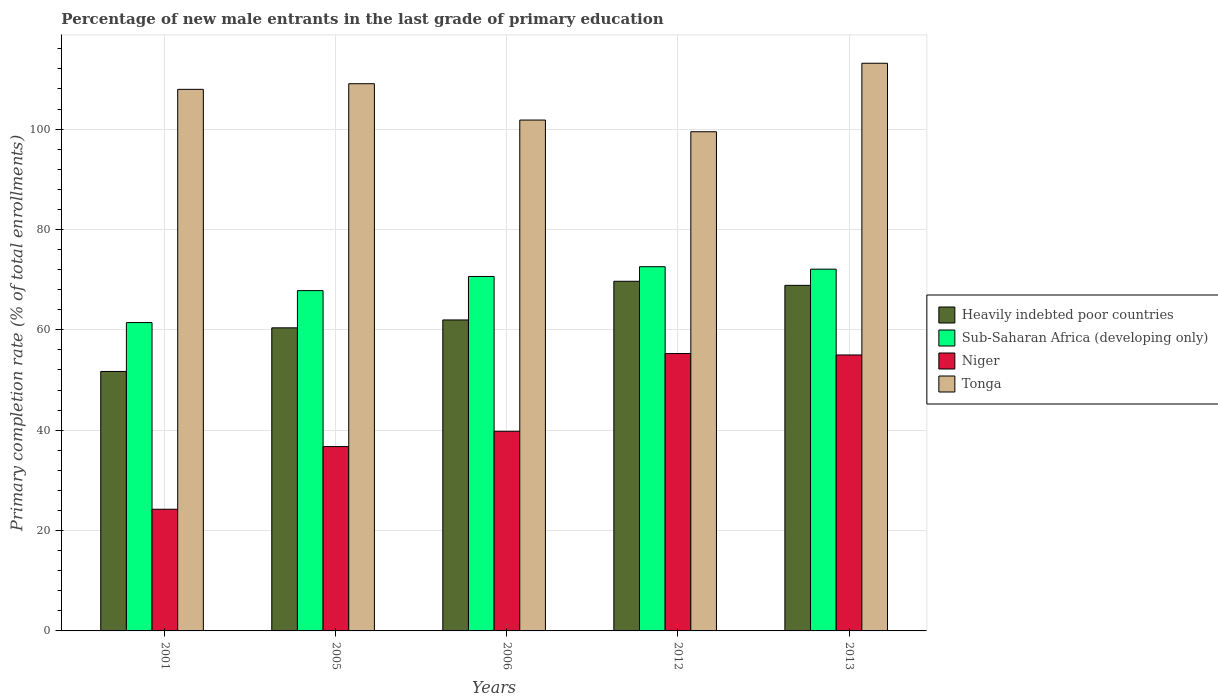How many groups of bars are there?
Ensure brevity in your answer.  5. Are the number of bars on each tick of the X-axis equal?
Offer a very short reply. Yes. What is the label of the 5th group of bars from the left?
Provide a succinct answer. 2013. In how many cases, is the number of bars for a given year not equal to the number of legend labels?
Offer a very short reply. 0. What is the percentage of new male entrants in Sub-Saharan Africa (developing only) in 2006?
Give a very brief answer. 70.63. Across all years, what is the maximum percentage of new male entrants in Heavily indebted poor countries?
Provide a short and direct response. 69.68. Across all years, what is the minimum percentage of new male entrants in Sub-Saharan Africa (developing only)?
Provide a succinct answer. 61.45. In which year was the percentage of new male entrants in Sub-Saharan Africa (developing only) maximum?
Give a very brief answer. 2012. In which year was the percentage of new male entrants in Heavily indebted poor countries minimum?
Offer a very short reply. 2001. What is the total percentage of new male entrants in Niger in the graph?
Offer a very short reply. 211.03. What is the difference between the percentage of new male entrants in Heavily indebted poor countries in 2001 and that in 2006?
Your answer should be very brief. -10.27. What is the difference between the percentage of new male entrants in Heavily indebted poor countries in 2005 and the percentage of new male entrants in Tonga in 2006?
Offer a terse response. -41.4. What is the average percentage of new male entrants in Heavily indebted poor countries per year?
Keep it short and to the point. 62.52. In the year 2001, what is the difference between the percentage of new male entrants in Sub-Saharan Africa (developing only) and percentage of new male entrants in Niger?
Your answer should be very brief. 37.2. In how many years, is the percentage of new male entrants in Sub-Saharan Africa (developing only) greater than 108 %?
Offer a terse response. 0. What is the ratio of the percentage of new male entrants in Sub-Saharan Africa (developing only) in 2001 to that in 2006?
Your answer should be very brief. 0.87. What is the difference between the highest and the second highest percentage of new male entrants in Niger?
Provide a short and direct response. 0.28. What is the difference between the highest and the lowest percentage of new male entrants in Sub-Saharan Africa (developing only)?
Ensure brevity in your answer.  11.13. In how many years, is the percentage of new male entrants in Heavily indebted poor countries greater than the average percentage of new male entrants in Heavily indebted poor countries taken over all years?
Offer a terse response. 2. Is it the case that in every year, the sum of the percentage of new male entrants in Niger and percentage of new male entrants in Heavily indebted poor countries is greater than the sum of percentage of new male entrants in Sub-Saharan Africa (developing only) and percentage of new male entrants in Tonga?
Provide a short and direct response. No. What does the 2nd bar from the left in 2001 represents?
Offer a very short reply. Sub-Saharan Africa (developing only). What does the 4th bar from the right in 2005 represents?
Your answer should be very brief. Heavily indebted poor countries. Are all the bars in the graph horizontal?
Offer a terse response. No. Are the values on the major ticks of Y-axis written in scientific E-notation?
Offer a terse response. No. Does the graph contain any zero values?
Provide a short and direct response. No. Does the graph contain grids?
Make the answer very short. Yes. How are the legend labels stacked?
Keep it short and to the point. Vertical. What is the title of the graph?
Offer a very short reply. Percentage of new male entrants in the last grade of primary education. Does "Zimbabwe" appear as one of the legend labels in the graph?
Provide a short and direct response. No. What is the label or title of the Y-axis?
Offer a very short reply. Primary completion rate (% of total enrollments). What is the Primary completion rate (% of total enrollments) in Heavily indebted poor countries in 2001?
Keep it short and to the point. 51.7. What is the Primary completion rate (% of total enrollments) of Sub-Saharan Africa (developing only) in 2001?
Your answer should be compact. 61.45. What is the Primary completion rate (% of total enrollments) in Niger in 2001?
Your answer should be compact. 24.25. What is the Primary completion rate (% of total enrollments) of Tonga in 2001?
Offer a very short reply. 107.92. What is the Primary completion rate (% of total enrollments) in Heavily indebted poor countries in 2005?
Offer a terse response. 60.4. What is the Primary completion rate (% of total enrollments) of Sub-Saharan Africa (developing only) in 2005?
Provide a succinct answer. 67.81. What is the Primary completion rate (% of total enrollments) of Niger in 2005?
Offer a very short reply. 36.73. What is the Primary completion rate (% of total enrollments) of Tonga in 2005?
Your answer should be very brief. 109.04. What is the Primary completion rate (% of total enrollments) of Heavily indebted poor countries in 2006?
Offer a very short reply. 61.97. What is the Primary completion rate (% of total enrollments) of Sub-Saharan Africa (developing only) in 2006?
Your answer should be compact. 70.63. What is the Primary completion rate (% of total enrollments) of Niger in 2006?
Ensure brevity in your answer.  39.78. What is the Primary completion rate (% of total enrollments) of Tonga in 2006?
Your answer should be very brief. 101.8. What is the Primary completion rate (% of total enrollments) in Heavily indebted poor countries in 2012?
Your response must be concise. 69.68. What is the Primary completion rate (% of total enrollments) in Sub-Saharan Africa (developing only) in 2012?
Make the answer very short. 72.57. What is the Primary completion rate (% of total enrollments) in Niger in 2012?
Keep it short and to the point. 55.28. What is the Primary completion rate (% of total enrollments) of Tonga in 2012?
Offer a very short reply. 99.47. What is the Primary completion rate (% of total enrollments) in Heavily indebted poor countries in 2013?
Ensure brevity in your answer.  68.86. What is the Primary completion rate (% of total enrollments) of Sub-Saharan Africa (developing only) in 2013?
Your response must be concise. 72.08. What is the Primary completion rate (% of total enrollments) of Niger in 2013?
Provide a succinct answer. 54.99. What is the Primary completion rate (% of total enrollments) in Tonga in 2013?
Your answer should be compact. 113.12. Across all years, what is the maximum Primary completion rate (% of total enrollments) of Heavily indebted poor countries?
Your answer should be compact. 69.68. Across all years, what is the maximum Primary completion rate (% of total enrollments) of Sub-Saharan Africa (developing only)?
Offer a terse response. 72.57. Across all years, what is the maximum Primary completion rate (% of total enrollments) of Niger?
Provide a short and direct response. 55.28. Across all years, what is the maximum Primary completion rate (% of total enrollments) of Tonga?
Offer a very short reply. 113.12. Across all years, what is the minimum Primary completion rate (% of total enrollments) in Heavily indebted poor countries?
Provide a succinct answer. 51.7. Across all years, what is the minimum Primary completion rate (% of total enrollments) of Sub-Saharan Africa (developing only)?
Give a very brief answer. 61.45. Across all years, what is the minimum Primary completion rate (% of total enrollments) of Niger?
Your response must be concise. 24.25. Across all years, what is the minimum Primary completion rate (% of total enrollments) of Tonga?
Offer a very short reply. 99.47. What is the total Primary completion rate (% of total enrollments) of Heavily indebted poor countries in the graph?
Provide a short and direct response. 312.6. What is the total Primary completion rate (% of total enrollments) in Sub-Saharan Africa (developing only) in the graph?
Make the answer very short. 344.55. What is the total Primary completion rate (% of total enrollments) in Niger in the graph?
Offer a terse response. 211.03. What is the total Primary completion rate (% of total enrollments) in Tonga in the graph?
Offer a terse response. 531.35. What is the difference between the Primary completion rate (% of total enrollments) in Heavily indebted poor countries in 2001 and that in 2005?
Ensure brevity in your answer.  -8.7. What is the difference between the Primary completion rate (% of total enrollments) of Sub-Saharan Africa (developing only) in 2001 and that in 2005?
Keep it short and to the point. -6.37. What is the difference between the Primary completion rate (% of total enrollments) in Niger in 2001 and that in 2005?
Offer a terse response. -12.49. What is the difference between the Primary completion rate (% of total enrollments) of Tonga in 2001 and that in 2005?
Your response must be concise. -1.12. What is the difference between the Primary completion rate (% of total enrollments) of Heavily indebted poor countries in 2001 and that in 2006?
Provide a short and direct response. -10.27. What is the difference between the Primary completion rate (% of total enrollments) in Sub-Saharan Africa (developing only) in 2001 and that in 2006?
Give a very brief answer. -9.18. What is the difference between the Primary completion rate (% of total enrollments) of Niger in 2001 and that in 2006?
Offer a very short reply. -15.54. What is the difference between the Primary completion rate (% of total enrollments) in Tonga in 2001 and that in 2006?
Your response must be concise. 6.12. What is the difference between the Primary completion rate (% of total enrollments) in Heavily indebted poor countries in 2001 and that in 2012?
Offer a terse response. -17.97. What is the difference between the Primary completion rate (% of total enrollments) of Sub-Saharan Africa (developing only) in 2001 and that in 2012?
Keep it short and to the point. -11.13. What is the difference between the Primary completion rate (% of total enrollments) in Niger in 2001 and that in 2012?
Give a very brief answer. -31.03. What is the difference between the Primary completion rate (% of total enrollments) of Tonga in 2001 and that in 2012?
Offer a terse response. 8.45. What is the difference between the Primary completion rate (% of total enrollments) in Heavily indebted poor countries in 2001 and that in 2013?
Make the answer very short. -17.16. What is the difference between the Primary completion rate (% of total enrollments) in Sub-Saharan Africa (developing only) in 2001 and that in 2013?
Your answer should be very brief. -10.64. What is the difference between the Primary completion rate (% of total enrollments) of Niger in 2001 and that in 2013?
Make the answer very short. -30.75. What is the difference between the Primary completion rate (% of total enrollments) in Tonga in 2001 and that in 2013?
Your response must be concise. -5.2. What is the difference between the Primary completion rate (% of total enrollments) of Heavily indebted poor countries in 2005 and that in 2006?
Your answer should be compact. -1.57. What is the difference between the Primary completion rate (% of total enrollments) of Sub-Saharan Africa (developing only) in 2005 and that in 2006?
Make the answer very short. -2.82. What is the difference between the Primary completion rate (% of total enrollments) of Niger in 2005 and that in 2006?
Offer a terse response. -3.05. What is the difference between the Primary completion rate (% of total enrollments) of Tonga in 2005 and that in 2006?
Keep it short and to the point. 7.24. What is the difference between the Primary completion rate (% of total enrollments) of Heavily indebted poor countries in 2005 and that in 2012?
Ensure brevity in your answer.  -9.28. What is the difference between the Primary completion rate (% of total enrollments) in Sub-Saharan Africa (developing only) in 2005 and that in 2012?
Make the answer very short. -4.76. What is the difference between the Primary completion rate (% of total enrollments) in Niger in 2005 and that in 2012?
Provide a short and direct response. -18.54. What is the difference between the Primary completion rate (% of total enrollments) in Tonga in 2005 and that in 2012?
Your answer should be very brief. 9.57. What is the difference between the Primary completion rate (% of total enrollments) of Heavily indebted poor countries in 2005 and that in 2013?
Your answer should be compact. -8.47. What is the difference between the Primary completion rate (% of total enrollments) of Sub-Saharan Africa (developing only) in 2005 and that in 2013?
Ensure brevity in your answer.  -4.27. What is the difference between the Primary completion rate (% of total enrollments) of Niger in 2005 and that in 2013?
Provide a short and direct response. -18.26. What is the difference between the Primary completion rate (% of total enrollments) in Tonga in 2005 and that in 2013?
Ensure brevity in your answer.  -4.08. What is the difference between the Primary completion rate (% of total enrollments) of Heavily indebted poor countries in 2006 and that in 2012?
Provide a succinct answer. -7.71. What is the difference between the Primary completion rate (% of total enrollments) in Sub-Saharan Africa (developing only) in 2006 and that in 2012?
Provide a succinct answer. -1.94. What is the difference between the Primary completion rate (% of total enrollments) in Niger in 2006 and that in 2012?
Ensure brevity in your answer.  -15.49. What is the difference between the Primary completion rate (% of total enrollments) of Tonga in 2006 and that in 2012?
Your answer should be compact. 2.33. What is the difference between the Primary completion rate (% of total enrollments) in Heavily indebted poor countries in 2006 and that in 2013?
Offer a terse response. -6.89. What is the difference between the Primary completion rate (% of total enrollments) of Sub-Saharan Africa (developing only) in 2006 and that in 2013?
Provide a short and direct response. -1.45. What is the difference between the Primary completion rate (% of total enrollments) in Niger in 2006 and that in 2013?
Give a very brief answer. -15.21. What is the difference between the Primary completion rate (% of total enrollments) of Tonga in 2006 and that in 2013?
Your answer should be very brief. -11.32. What is the difference between the Primary completion rate (% of total enrollments) in Heavily indebted poor countries in 2012 and that in 2013?
Provide a short and direct response. 0.81. What is the difference between the Primary completion rate (% of total enrollments) of Sub-Saharan Africa (developing only) in 2012 and that in 2013?
Offer a very short reply. 0.49. What is the difference between the Primary completion rate (% of total enrollments) of Niger in 2012 and that in 2013?
Your response must be concise. 0.28. What is the difference between the Primary completion rate (% of total enrollments) of Tonga in 2012 and that in 2013?
Make the answer very short. -13.65. What is the difference between the Primary completion rate (% of total enrollments) of Heavily indebted poor countries in 2001 and the Primary completion rate (% of total enrollments) of Sub-Saharan Africa (developing only) in 2005?
Make the answer very short. -16.11. What is the difference between the Primary completion rate (% of total enrollments) of Heavily indebted poor countries in 2001 and the Primary completion rate (% of total enrollments) of Niger in 2005?
Provide a short and direct response. 14.97. What is the difference between the Primary completion rate (% of total enrollments) in Heavily indebted poor countries in 2001 and the Primary completion rate (% of total enrollments) in Tonga in 2005?
Your response must be concise. -57.34. What is the difference between the Primary completion rate (% of total enrollments) in Sub-Saharan Africa (developing only) in 2001 and the Primary completion rate (% of total enrollments) in Niger in 2005?
Offer a terse response. 24.72. What is the difference between the Primary completion rate (% of total enrollments) of Sub-Saharan Africa (developing only) in 2001 and the Primary completion rate (% of total enrollments) of Tonga in 2005?
Your answer should be compact. -47.59. What is the difference between the Primary completion rate (% of total enrollments) of Niger in 2001 and the Primary completion rate (% of total enrollments) of Tonga in 2005?
Make the answer very short. -84.8. What is the difference between the Primary completion rate (% of total enrollments) of Heavily indebted poor countries in 2001 and the Primary completion rate (% of total enrollments) of Sub-Saharan Africa (developing only) in 2006?
Your response must be concise. -18.93. What is the difference between the Primary completion rate (% of total enrollments) in Heavily indebted poor countries in 2001 and the Primary completion rate (% of total enrollments) in Niger in 2006?
Ensure brevity in your answer.  11.92. What is the difference between the Primary completion rate (% of total enrollments) of Heavily indebted poor countries in 2001 and the Primary completion rate (% of total enrollments) of Tonga in 2006?
Your response must be concise. -50.1. What is the difference between the Primary completion rate (% of total enrollments) in Sub-Saharan Africa (developing only) in 2001 and the Primary completion rate (% of total enrollments) in Niger in 2006?
Offer a terse response. 21.66. What is the difference between the Primary completion rate (% of total enrollments) of Sub-Saharan Africa (developing only) in 2001 and the Primary completion rate (% of total enrollments) of Tonga in 2006?
Your answer should be very brief. -40.35. What is the difference between the Primary completion rate (% of total enrollments) in Niger in 2001 and the Primary completion rate (% of total enrollments) in Tonga in 2006?
Provide a short and direct response. -77.55. What is the difference between the Primary completion rate (% of total enrollments) in Heavily indebted poor countries in 2001 and the Primary completion rate (% of total enrollments) in Sub-Saharan Africa (developing only) in 2012?
Your answer should be compact. -20.87. What is the difference between the Primary completion rate (% of total enrollments) of Heavily indebted poor countries in 2001 and the Primary completion rate (% of total enrollments) of Niger in 2012?
Your response must be concise. -3.57. What is the difference between the Primary completion rate (% of total enrollments) of Heavily indebted poor countries in 2001 and the Primary completion rate (% of total enrollments) of Tonga in 2012?
Provide a succinct answer. -47.77. What is the difference between the Primary completion rate (% of total enrollments) in Sub-Saharan Africa (developing only) in 2001 and the Primary completion rate (% of total enrollments) in Niger in 2012?
Your answer should be compact. 6.17. What is the difference between the Primary completion rate (% of total enrollments) in Sub-Saharan Africa (developing only) in 2001 and the Primary completion rate (% of total enrollments) in Tonga in 2012?
Your response must be concise. -38.02. What is the difference between the Primary completion rate (% of total enrollments) of Niger in 2001 and the Primary completion rate (% of total enrollments) of Tonga in 2012?
Provide a short and direct response. -75.22. What is the difference between the Primary completion rate (% of total enrollments) in Heavily indebted poor countries in 2001 and the Primary completion rate (% of total enrollments) in Sub-Saharan Africa (developing only) in 2013?
Your response must be concise. -20.38. What is the difference between the Primary completion rate (% of total enrollments) of Heavily indebted poor countries in 2001 and the Primary completion rate (% of total enrollments) of Niger in 2013?
Provide a succinct answer. -3.29. What is the difference between the Primary completion rate (% of total enrollments) in Heavily indebted poor countries in 2001 and the Primary completion rate (% of total enrollments) in Tonga in 2013?
Make the answer very short. -61.42. What is the difference between the Primary completion rate (% of total enrollments) of Sub-Saharan Africa (developing only) in 2001 and the Primary completion rate (% of total enrollments) of Niger in 2013?
Offer a terse response. 6.46. What is the difference between the Primary completion rate (% of total enrollments) of Sub-Saharan Africa (developing only) in 2001 and the Primary completion rate (% of total enrollments) of Tonga in 2013?
Offer a terse response. -51.67. What is the difference between the Primary completion rate (% of total enrollments) in Niger in 2001 and the Primary completion rate (% of total enrollments) in Tonga in 2013?
Your response must be concise. -88.87. What is the difference between the Primary completion rate (% of total enrollments) of Heavily indebted poor countries in 2005 and the Primary completion rate (% of total enrollments) of Sub-Saharan Africa (developing only) in 2006?
Provide a succinct answer. -10.23. What is the difference between the Primary completion rate (% of total enrollments) of Heavily indebted poor countries in 2005 and the Primary completion rate (% of total enrollments) of Niger in 2006?
Make the answer very short. 20.61. What is the difference between the Primary completion rate (% of total enrollments) of Heavily indebted poor countries in 2005 and the Primary completion rate (% of total enrollments) of Tonga in 2006?
Give a very brief answer. -41.4. What is the difference between the Primary completion rate (% of total enrollments) of Sub-Saharan Africa (developing only) in 2005 and the Primary completion rate (% of total enrollments) of Niger in 2006?
Your response must be concise. 28.03. What is the difference between the Primary completion rate (% of total enrollments) of Sub-Saharan Africa (developing only) in 2005 and the Primary completion rate (% of total enrollments) of Tonga in 2006?
Your response must be concise. -33.99. What is the difference between the Primary completion rate (% of total enrollments) of Niger in 2005 and the Primary completion rate (% of total enrollments) of Tonga in 2006?
Ensure brevity in your answer.  -65.07. What is the difference between the Primary completion rate (% of total enrollments) of Heavily indebted poor countries in 2005 and the Primary completion rate (% of total enrollments) of Sub-Saharan Africa (developing only) in 2012?
Keep it short and to the point. -12.18. What is the difference between the Primary completion rate (% of total enrollments) in Heavily indebted poor countries in 2005 and the Primary completion rate (% of total enrollments) in Niger in 2012?
Keep it short and to the point. 5.12. What is the difference between the Primary completion rate (% of total enrollments) in Heavily indebted poor countries in 2005 and the Primary completion rate (% of total enrollments) in Tonga in 2012?
Make the answer very short. -39.07. What is the difference between the Primary completion rate (% of total enrollments) of Sub-Saharan Africa (developing only) in 2005 and the Primary completion rate (% of total enrollments) of Niger in 2012?
Provide a short and direct response. 12.54. What is the difference between the Primary completion rate (% of total enrollments) of Sub-Saharan Africa (developing only) in 2005 and the Primary completion rate (% of total enrollments) of Tonga in 2012?
Make the answer very short. -31.66. What is the difference between the Primary completion rate (% of total enrollments) of Niger in 2005 and the Primary completion rate (% of total enrollments) of Tonga in 2012?
Offer a very short reply. -62.74. What is the difference between the Primary completion rate (% of total enrollments) in Heavily indebted poor countries in 2005 and the Primary completion rate (% of total enrollments) in Sub-Saharan Africa (developing only) in 2013?
Provide a succinct answer. -11.69. What is the difference between the Primary completion rate (% of total enrollments) in Heavily indebted poor countries in 2005 and the Primary completion rate (% of total enrollments) in Niger in 2013?
Your response must be concise. 5.41. What is the difference between the Primary completion rate (% of total enrollments) of Heavily indebted poor countries in 2005 and the Primary completion rate (% of total enrollments) of Tonga in 2013?
Ensure brevity in your answer.  -52.72. What is the difference between the Primary completion rate (% of total enrollments) of Sub-Saharan Africa (developing only) in 2005 and the Primary completion rate (% of total enrollments) of Niger in 2013?
Offer a very short reply. 12.82. What is the difference between the Primary completion rate (% of total enrollments) of Sub-Saharan Africa (developing only) in 2005 and the Primary completion rate (% of total enrollments) of Tonga in 2013?
Your answer should be very brief. -45.3. What is the difference between the Primary completion rate (% of total enrollments) in Niger in 2005 and the Primary completion rate (% of total enrollments) in Tonga in 2013?
Provide a succinct answer. -76.39. What is the difference between the Primary completion rate (% of total enrollments) in Heavily indebted poor countries in 2006 and the Primary completion rate (% of total enrollments) in Sub-Saharan Africa (developing only) in 2012?
Provide a short and direct response. -10.61. What is the difference between the Primary completion rate (% of total enrollments) of Heavily indebted poor countries in 2006 and the Primary completion rate (% of total enrollments) of Niger in 2012?
Provide a succinct answer. 6.69. What is the difference between the Primary completion rate (% of total enrollments) of Heavily indebted poor countries in 2006 and the Primary completion rate (% of total enrollments) of Tonga in 2012?
Provide a succinct answer. -37.5. What is the difference between the Primary completion rate (% of total enrollments) in Sub-Saharan Africa (developing only) in 2006 and the Primary completion rate (% of total enrollments) in Niger in 2012?
Offer a terse response. 15.36. What is the difference between the Primary completion rate (% of total enrollments) of Sub-Saharan Africa (developing only) in 2006 and the Primary completion rate (% of total enrollments) of Tonga in 2012?
Provide a succinct answer. -28.84. What is the difference between the Primary completion rate (% of total enrollments) in Niger in 2006 and the Primary completion rate (% of total enrollments) in Tonga in 2012?
Your answer should be very brief. -59.69. What is the difference between the Primary completion rate (% of total enrollments) in Heavily indebted poor countries in 2006 and the Primary completion rate (% of total enrollments) in Sub-Saharan Africa (developing only) in 2013?
Offer a very short reply. -10.12. What is the difference between the Primary completion rate (% of total enrollments) of Heavily indebted poor countries in 2006 and the Primary completion rate (% of total enrollments) of Niger in 2013?
Offer a very short reply. 6.98. What is the difference between the Primary completion rate (% of total enrollments) in Heavily indebted poor countries in 2006 and the Primary completion rate (% of total enrollments) in Tonga in 2013?
Your answer should be very brief. -51.15. What is the difference between the Primary completion rate (% of total enrollments) in Sub-Saharan Africa (developing only) in 2006 and the Primary completion rate (% of total enrollments) in Niger in 2013?
Offer a terse response. 15.64. What is the difference between the Primary completion rate (% of total enrollments) of Sub-Saharan Africa (developing only) in 2006 and the Primary completion rate (% of total enrollments) of Tonga in 2013?
Your answer should be compact. -42.49. What is the difference between the Primary completion rate (% of total enrollments) of Niger in 2006 and the Primary completion rate (% of total enrollments) of Tonga in 2013?
Your answer should be very brief. -73.33. What is the difference between the Primary completion rate (% of total enrollments) in Heavily indebted poor countries in 2012 and the Primary completion rate (% of total enrollments) in Sub-Saharan Africa (developing only) in 2013?
Offer a very short reply. -2.41. What is the difference between the Primary completion rate (% of total enrollments) of Heavily indebted poor countries in 2012 and the Primary completion rate (% of total enrollments) of Niger in 2013?
Give a very brief answer. 14.68. What is the difference between the Primary completion rate (% of total enrollments) of Heavily indebted poor countries in 2012 and the Primary completion rate (% of total enrollments) of Tonga in 2013?
Keep it short and to the point. -43.44. What is the difference between the Primary completion rate (% of total enrollments) in Sub-Saharan Africa (developing only) in 2012 and the Primary completion rate (% of total enrollments) in Niger in 2013?
Provide a short and direct response. 17.58. What is the difference between the Primary completion rate (% of total enrollments) in Sub-Saharan Africa (developing only) in 2012 and the Primary completion rate (% of total enrollments) in Tonga in 2013?
Offer a terse response. -40.54. What is the difference between the Primary completion rate (% of total enrollments) of Niger in 2012 and the Primary completion rate (% of total enrollments) of Tonga in 2013?
Provide a succinct answer. -57.84. What is the average Primary completion rate (% of total enrollments) in Heavily indebted poor countries per year?
Keep it short and to the point. 62.52. What is the average Primary completion rate (% of total enrollments) in Sub-Saharan Africa (developing only) per year?
Provide a succinct answer. 68.91. What is the average Primary completion rate (% of total enrollments) in Niger per year?
Offer a terse response. 42.21. What is the average Primary completion rate (% of total enrollments) of Tonga per year?
Provide a short and direct response. 106.27. In the year 2001, what is the difference between the Primary completion rate (% of total enrollments) of Heavily indebted poor countries and Primary completion rate (% of total enrollments) of Sub-Saharan Africa (developing only)?
Provide a short and direct response. -9.75. In the year 2001, what is the difference between the Primary completion rate (% of total enrollments) in Heavily indebted poor countries and Primary completion rate (% of total enrollments) in Niger?
Ensure brevity in your answer.  27.46. In the year 2001, what is the difference between the Primary completion rate (% of total enrollments) of Heavily indebted poor countries and Primary completion rate (% of total enrollments) of Tonga?
Ensure brevity in your answer.  -56.22. In the year 2001, what is the difference between the Primary completion rate (% of total enrollments) of Sub-Saharan Africa (developing only) and Primary completion rate (% of total enrollments) of Niger?
Give a very brief answer. 37.2. In the year 2001, what is the difference between the Primary completion rate (% of total enrollments) of Sub-Saharan Africa (developing only) and Primary completion rate (% of total enrollments) of Tonga?
Give a very brief answer. -46.47. In the year 2001, what is the difference between the Primary completion rate (% of total enrollments) of Niger and Primary completion rate (% of total enrollments) of Tonga?
Offer a terse response. -83.67. In the year 2005, what is the difference between the Primary completion rate (% of total enrollments) in Heavily indebted poor countries and Primary completion rate (% of total enrollments) in Sub-Saharan Africa (developing only)?
Your answer should be very brief. -7.42. In the year 2005, what is the difference between the Primary completion rate (% of total enrollments) in Heavily indebted poor countries and Primary completion rate (% of total enrollments) in Niger?
Offer a terse response. 23.67. In the year 2005, what is the difference between the Primary completion rate (% of total enrollments) of Heavily indebted poor countries and Primary completion rate (% of total enrollments) of Tonga?
Ensure brevity in your answer.  -48.65. In the year 2005, what is the difference between the Primary completion rate (% of total enrollments) in Sub-Saharan Africa (developing only) and Primary completion rate (% of total enrollments) in Niger?
Provide a short and direct response. 31.08. In the year 2005, what is the difference between the Primary completion rate (% of total enrollments) in Sub-Saharan Africa (developing only) and Primary completion rate (% of total enrollments) in Tonga?
Give a very brief answer. -41.23. In the year 2005, what is the difference between the Primary completion rate (% of total enrollments) of Niger and Primary completion rate (% of total enrollments) of Tonga?
Keep it short and to the point. -72.31. In the year 2006, what is the difference between the Primary completion rate (% of total enrollments) in Heavily indebted poor countries and Primary completion rate (% of total enrollments) in Sub-Saharan Africa (developing only)?
Make the answer very short. -8.66. In the year 2006, what is the difference between the Primary completion rate (% of total enrollments) in Heavily indebted poor countries and Primary completion rate (% of total enrollments) in Niger?
Offer a very short reply. 22.18. In the year 2006, what is the difference between the Primary completion rate (% of total enrollments) of Heavily indebted poor countries and Primary completion rate (% of total enrollments) of Tonga?
Give a very brief answer. -39.83. In the year 2006, what is the difference between the Primary completion rate (% of total enrollments) in Sub-Saharan Africa (developing only) and Primary completion rate (% of total enrollments) in Niger?
Offer a very short reply. 30.85. In the year 2006, what is the difference between the Primary completion rate (% of total enrollments) of Sub-Saharan Africa (developing only) and Primary completion rate (% of total enrollments) of Tonga?
Make the answer very short. -31.17. In the year 2006, what is the difference between the Primary completion rate (% of total enrollments) of Niger and Primary completion rate (% of total enrollments) of Tonga?
Make the answer very short. -62.02. In the year 2012, what is the difference between the Primary completion rate (% of total enrollments) of Heavily indebted poor countries and Primary completion rate (% of total enrollments) of Sub-Saharan Africa (developing only)?
Make the answer very short. -2.9. In the year 2012, what is the difference between the Primary completion rate (% of total enrollments) in Heavily indebted poor countries and Primary completion rate (% of total enrollments) in Niger?
Offer a very short reply. 14.4. In the year 2012, what is the difference between the Primary completion rate (% of total enrollments) of Heavily indebted poor countries and Primary completion rate (% of total enrollments) of Tonga?
Keep it short and to the point. -29.79. In the year 2012, what is the difference between the Primary completion rate (% of total enrollments) in Sub-Saharan Africa (developing only) and Primary completion rate (% of total enrollments) in Niger?
Give a very brief answer. 17.3. In the year 2012, what is the difference between the Primary completion rate (% of total enrollments) in Sub-Saharan Africa (developing only) and Primary completion rate (% of total enrollments) in Tonga?
Offer a very short reply. -26.89. In the year 2012, what is the difference between the Primary completion rate (% of total enrollments) of Niger and Primary completion rate (% of total enrollments) of Tonga?
Your answer should be compact. -44.19. In the year 2013, what is the difference between the Primary completion rate (% of total enrollments) of Heavily indebted poor countries and Primary completion rate (% of total enrollments) of Sub-Saharan Africa (developing only)?
Your response must be concise. -3.22. In the year 2013, what is the difference between the Primary completion rate (% of total enrollments) of Heavily indebted poor countries and Primary completion rate (% of total enrollments) of Niger?
Your answer should be very brief. 13.87. In the year 2013, what is the difference between the Primary completion rate (% of total enrollments) of Heavily indebted poor countries and Primary completion rate (% of total enrollments) of Tonga?
Your answer should be compact. -44.26. In the year 2013, what is the difference between the Primary completion rate (% of total enrollments) in Sub-Saharan Africa (developing only) and Primary completion rate (% of total enrollments) in Niger?
Make the answer very short. 17.09. In the year 2013, what is the difference between the Primary completion rate (% of total enrollments) in Sub-Saharan Africa (developing only) and Primary completion rate (% of total enrollments) in Tonga?
Make the answer very short. -41.03. In the year 2013, what is the difference between the Primary completion rate (% of total enrollments) in Niger and Primary completion rate (% of total enrollments) in Tonga?
Provide a short and direct response. -58.13. What is the ratio of the Primary completion rate (% of total enrollments) in Heavily indebted poor countries in 2001 to that in 2005?
Give a very brief answer. 0.86. What is the ratio of the Primary completion rate (% of total enrollments) of Sub-Saharan Africa (developing only) in 2001 to that in 2005?
Ensure brevity in your answer.  0.91. What is the ratio of the Primary completion rate (% of total enrollments) in Niger in 2001 to that in 2005?
Make the answer very short. 0.66. What is the ratio of the Primary completion rate (% of total enrollments) of Tonga in 2001 to that in 2005?
Your answer should be very brief. 0.99. What is the ratio of the Primary completion rate (% of total enrollments) of Heavily indebted poor countries in 2001 to that in 2006?
Offer a terse response. 0.83. What is the ratio of the Primary completion rate (% of total enrollments) in Sub-Saharan Africa (developing only) in 2001 to that in 2006?
Offer a very short reply. 0.87. What is the ratio of the Primary completion rate (% of total enrollments) of Niger in 2001 to that in 2006?
Make the answer very short. 0.61. What is the ratio of the Primary completion rate (% of total enrollments) of Tonga in 2001 to that in 2006?
Keep it short and to the point. 1.06. What is the ratio of the Primary completion rate (% of total enrollments) of Heavily indebted poor countries in 2001 to that in 2012?
Make the answer very short. 0.74. What is the ratio of the Primary completion rate (% of total enrollments) in Sub-Saharan Africa (developing only) in 2001 to that in 2012?
Ensure brevity in your answer.  0.85. What is the ratio of the Primary completion rate (% of total enrollments) in Niger in 2001 to that in 2012?
Provide a succinct answer. 0.44. What is the ratio of the Primary completion rate (% of total enrollments) in Tonga in 2001 to that in 2012?
Your answer should be very brief. 1.08. What is the ratio of the Primary completion rate (% of total enrollments) of Heavily indebted poor countries in 2001 to that in 2013?
Offer a very short reply. 0.75. What is the ratio of the Primary completion rate (% of total enrollments) of Sub-Saharan Africa (developing only) in 2001 to that in 2013?
Provide a succinct answer. 0.85. What is the ratio of the Primary completion rate (% of total enrollments) in Niger in 2001 to that in 2013?
Offer a very short reply. 0.44. What is the ratio of the Primary completion rate (% of total enrollments) of Tonga in 2001 to that in 2013?
Give a very brief answer. 0.95. What is the ratio of the Primary completion rate (% of total enrollments) in Heavily indebted poor countries in 2005 to that in 2006?
Keep it short and to the point. 0.97. What is the ratio of the Primary completion rate (% of total enrollments) in Sub-Saharan Africa (developing only) in 2005 to that in 2006?
Keep it short and to the point. 0.96. What is the ratio of the Primary completion rate (% of total enrollments) of Niger in 2005 to that in 2006?
Your response must be concise. 0.92. What is the ratio of the Primary completion rate (% of total enrollments) in Tonga in 2005 to that in 2006?
Make the answer very short. 1.07. What is the ratio of the Primary completion rate (% of total enrollments) in Heavily indebted poor countries in 2005 to that in 2012?
Make the answer very short. 0.87. What is the ratio of the Primary completion rate (% of total enrollments) of Sub-Saharan Africa (developing only) in 2005 to that in 2012?
Keep it short and to the point. 0.93. What is the ratio of the Primary completion rate (% of total enrollments) in Niger in 2005 to that in 2012?
Your answer should be compact. 0.66. What is the ratio of the Primary completion rate (% of total enrollments) of Tonga in 2005 to that in 2012?
Offer a terse response. 1.1. What is the ratio of the Primary completion rate (% of total enrollments) of Heavily indebted poor countries in 2005 to that in 2013?
Your response must be concise. 0.88. What is the ratio of the Primary completion rate (% of total enrollments) in Sub-Saharan Africa (developing only) in 2005 to that in 2013?
Your response must be concise. 0.94. What is the ratio of the Primary completion rate (% of total enrollments) in Niger in 2005 to that in 2013?
Your answer should be compact. 0.67. What is the ratio of the Primary completion rate (% of total enrollments) in Heavily indebted poor countries in 2006 to that in 2012?
Make the answer very short. 0.89. What is the ratio of the Primary completion rate (% of total enrollments) in Sub-Saharan Africa (developing only) in 2006 to that in 2012?
Provide a short and direct response. 0.97. What is the ratio of the Primary completion rate (% of total enrollments) of Niger in 2006 to that in 2012?
Offer a terse response. 0.72. What is the ratio of the Primary completion rate (% of total enrollments) in Tonga in 2006 to that in 2012?
Give a very brief answer. 1.02. What is the ratio of the Primary completion rate (% of total enrollments) of Heavily indebted poor countries in 2006 to that in 2013?
Your answer should be very brief. 0.9. What is the ratio of the Primary completion rate (% of total enrollments) in Sub-Saharan Africa (developing only) in 2006 to that in 2013?
Your response must be concise. 0.98. What is the ratio of the Primary completion rate (% of total enrollments) of Niger in 2006 to that in 2013?
Your answer should be compact. 0.72. What is the ratio of the Primary completion rate (% of total enrollments) in Tonga in 2006 to that in 2013?
Your response must be concise. 0.9. What is the ratio of the Primary completion rate (% of total enrollments) of Heavily indebted poor countries in 2012 to that in 2013?
Ensure brevity in your answer.  1.01. What is the ratio of the Primary completion rate (% of total enrollments) of Sub-Saharan Africa (developing only) in 2012 to that in 2013?
Provide a succinct answer. 1.01. What is the ratio of the Primary completion rate (% of total enrollments) of Niger in 2012 to that in 2013?
Offer a terse response. 1.01. What is the ratio of the Primary completion rate (% of total enrollments) in Tonga in 2012 to that in 2013?
Your response must be concise. 0.88. What is the difference between the highest and the second highest Primary completion rate (% of total enrollments) of Heavily indebted poor countries?
Your answer should be very brief. 0.81. What is the difference between the highest and the second highest Primary completion rate (% of total enrollments) of Sub-Saharan Africa (developing only)?
Keep it short and to the point. 0.49. What is the difference between the highest and the second highest Primary completion rate (% of total enrollments) in Niger?
Give a very brief answer. 0.28. What is the difference between the highest and the second highest Primary completion rate (% of total enrollments) in Tonga?
Give a very brief answer. 4.08. What is the difference between the highest and the lowest Primary completion rate (% of total enrollments) in Heavily indebted poor countries?
Keep it short and to the point. 17.97. What is the difference between the highest and the lowest Primary completion rate (% of total enrollments) of Sub-Saharan Africa (developing only)?
Provide a short and direct response. 11.13. What is the difference between the highest and the lowest Primary completion rate (% of total enrollments) in Niger?
Offer a very short reply. 31.03. What is the difference between the highest and the lowest Primary completion rate (% of total enrollments) of Tonga?
Ensure brevity in your answer.  13.65. 